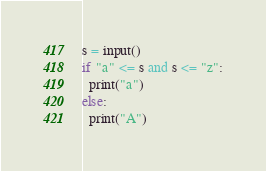Convert code to text. <code><loc_0><loc_0><loc_500><loc_500><_Python_>s = input()
if "a" <= s and s <= "z":
  print("a")
else:
  print("A")</code> 